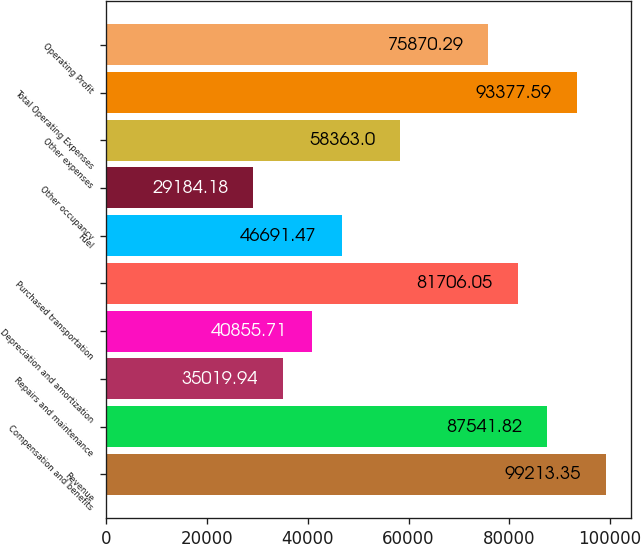Convert chart to OTSL. <chart><loc_0><loc_0><loc_500><loc_500><bar_chart><fcel>Revenue<fcel>Compensation and benefits<fcel>Repairs and maintenance<fcel>Depreciation and amortization<fcel>Purchased transportation<fcel>Fuel<fcel>Other occupancy<fcel>Other expenses<fcel>Total Operating Expenses<fcel>Operating Profit<nl><fcel>99213.4<fcel>87541.8<fcel>35019.9<fcel>40855.7<fcel>81706.1<fcel>46691.5<fcel>29184.2<fcel>58363<fcel>93377.6<fcel>75870.3<nl></chart> 